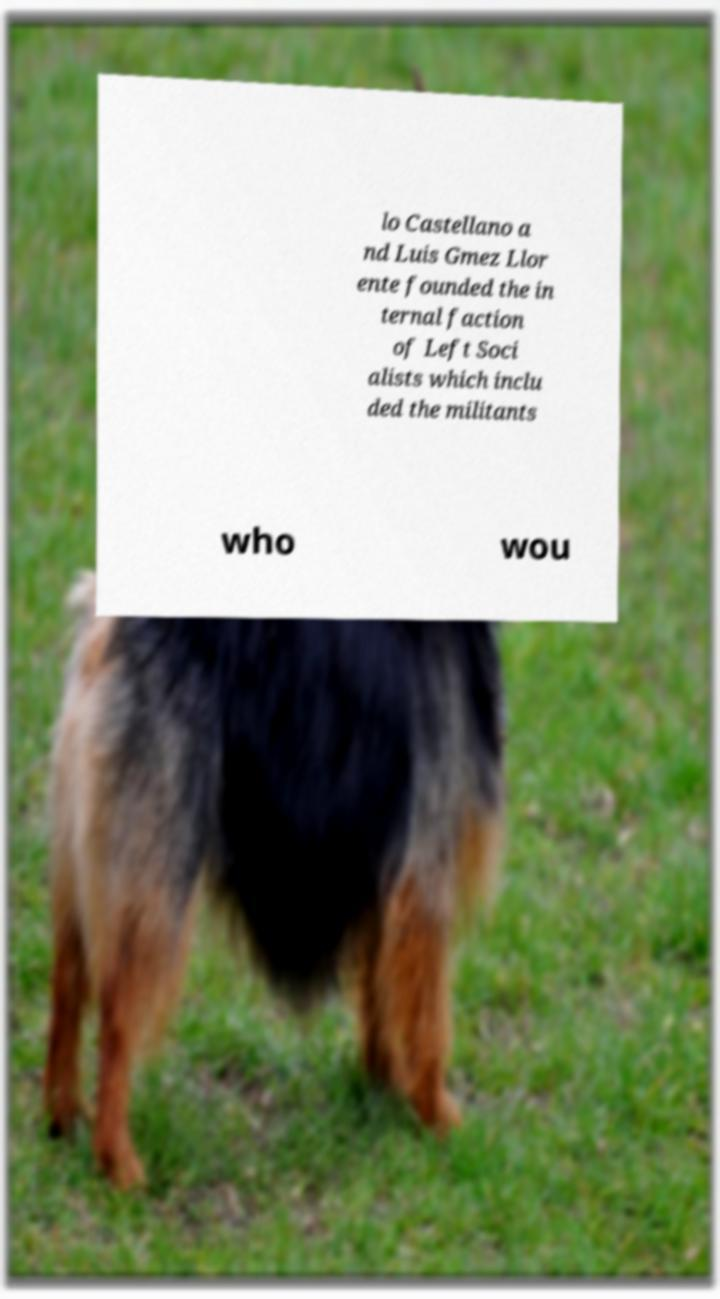Please read and relay the text visible in this image. What does it say? lo Castellano a nd Luis Gmez Llor ente founded the in ternal faction of Left Soci alists which inclu ded the militants who wou 